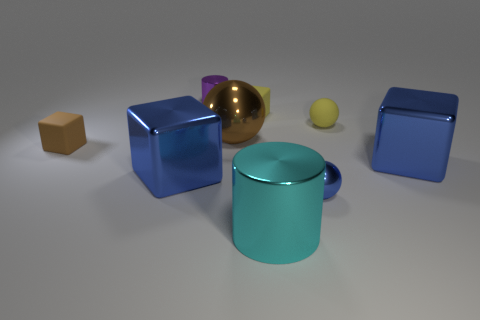Is the shape of the small yellow rubber thing in front of the yellow matte block the same as  the cyan metal object?
Make the answer very short. No. There is a big blue thing that is to the left of the large object that is to the right of the tiny metal ball; what is its shape?
Give a very brief answer. Cube. There is a small matte object that is the same shape as the tiny blue metal thing; what color is it?
Provide a short and direct response. Yellow. Does the small metallic sphere have the same color as the shiny block that is left of the yellow sphere?
Make the answer very short. Yes. What is the shape of the tiny thing that is both to the right of the small brown thing and in front of the large shiny sphere?
Your answer should be very brief. Sphere. Is the number of brown objects less than the number of balls?
Make the answer very short. Yes. Is there a tiny yellow thing?
Ensure brevity in your answer.  Yes. How many other things are there of the same size as the cyan metallic object?
Your answer should be very brief. 3. Is the small yellow sphere made of the same material as the tiny yellow thing on the left side of the big cylinder?
Your answer should be very brief. Yes. Is the number of large metallic spheres that are left of the large brown ball the same as the number of small shiny objects right of the small metallic cylinder?
Give a very brief answer. No. 